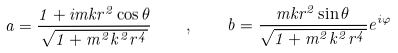Convert formula to latex. <formula><loc_0><loc_0><loc_500><loc_500>a = \frac { 1 + i m k r ^ { 2 } \cos \theta } { \sqrt { 1 + m ^ { 2 } k ^ { 2 } r ^ { 4 } } } \quad , \quad b = \frac { m k r ^ { 2 } \sin \theta } { \sqrt { 1 + m ^ { 2 } k ^ { 2 } r ^ { 4 } } } e ^ { i \varphi }</formula> 